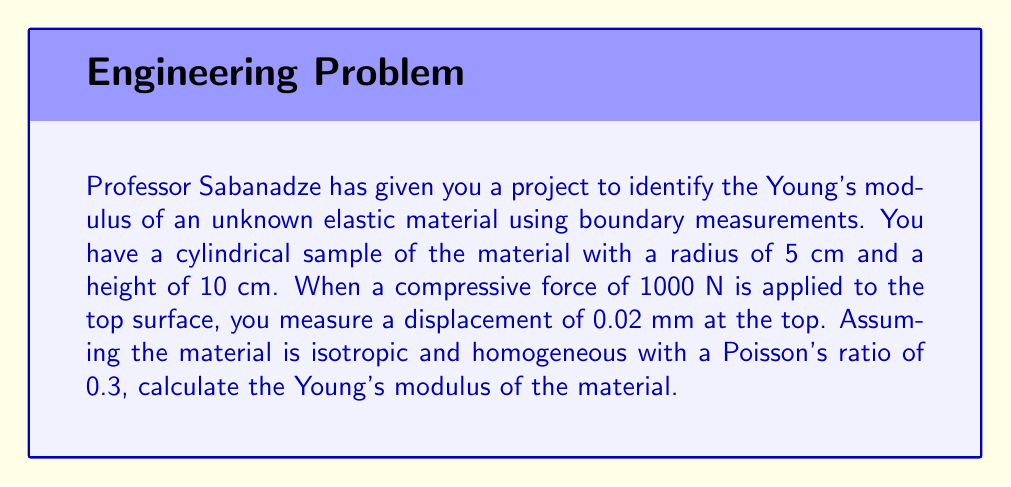Show me your answer to this math problem. Let's approach this step-by-step:

1) For a cylindrical sample under axial compression, we can use the relationship:

   $$E = \frac{FL}{A\Delta L}$$

   where:
   $E$ is Young's modulus
   $F$ is the applied force
   $L$ is the original length
   $A$ is the cross-sectional area
   $\Delta L$ is the change in length

2) We know:
   $F = 1000 \text{ N}$
   $L = 10 \text{ cm} = 0.1 \text{ m}$
   $\Delta L = 0.02 \text{ mm} = 2 \times 10^{-5} \text{ m}$
   $r = 5 \text{ cm} = 0.05 \text{ m}$ (radius)

3) Calculate the cross-sectional area:
   $$A = \pi r^2 = \pi (0.05)^2 = 7.854 \times 10^{-3} \text{ m}^2$$

4) Now, let's substitute these values into our equation:

   $$E = \frac{1000 \text{ N} \times 0.1 \text{ m}}{(7.854 \times 10^{-3} \text{ m}^2) \times (2 \times 10^{-5} \text{ m})}$$

5) Simplify:
   $$E = \frac{100}{1.5708 \times 10^{-7}} = 6.366 \times 10^8 \text{ Pa} = 636.6 \text{ MPa}$$

Therefore, the Young's modulus of the material is approximately 636.6 MPa.
Answer: 636.6 MPa 